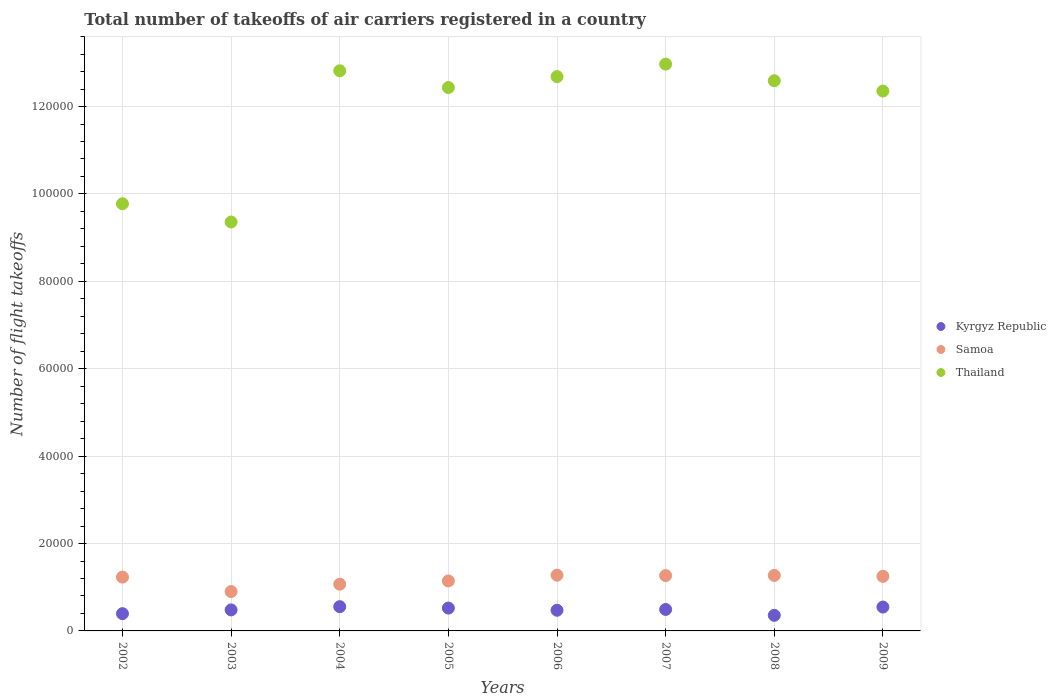How many different coloured dotlines are there?
Offer a terse response. 3. What is the total number of flight takeoffs in Kyrgyz Republic in 2006?
Provide a short and direct response. 4730. Across all years, what is the maximum total number of flight takeoffs in Samoa?
Provide a succinct answer. 1.28e+04. Across all years, what is the minimum total number of flight takeoffs in Kyrgyz Republic?
Your answer should be very brief. 3567. In which year was the total number of flight takeoffs in Thailand minimum?
Your answer should be very brief. 2003. What is the total total number of flight takeoffs in Thailand in the graph?
Keep it short and to the point. 9.50e+05. What is the difference between the total number of flight takeoffs in Samoa in 2002 and that in 2008?
Ensure brevity in your answer.  -382. What is the difference between the total number of flight takeoffs in Samoa in 2008 and the total number of flight takeoffs in Thailand in 2009?
Your response must be concise. -1.11e+05. What is the average total number of flight takeoffs in Samoa per year?
Your response must be concise. 1.18e+04. In the year 2006, what is the difference between the total number of flight takeoffs in Kyrgyz Republic and total number of flight takeoffs in Thailand?
Make the answer very short. -1.22e+05. In how many years, is the total number of flight takeoffs in Kyrgyz Republic greater than 4000?
Your answer should be compact. 6. What is the ratio of the total number of flight takeoffs in Kyrgyz Republic in 2003 to that in 2005?
Keep it short and to the point. 0.92. Is the total number of flight takeoffs in Kyrgyz Republic in 2006 less than that in 2009?
Provide a short and direct response. Yes. Is the difference between the total number of flight takeoffs in Kyrgyz Republic in 2002 and 2007 greater than the difference between the total number of flight takeoffs in Thailand in 2002 and 2007?
Ensure brevity in your answer.  Yes. What is the difference between the highest and the second highest total number of flight takeoffs in Kyrgyz Republic?
Give a very brief answer. 91. What is the difference between the highest and the lowest total number of flight takeoffs in Samoa?
Make the answer very short. 3742. Is the sum of the total number of flight takeoffs in Kyrgyz Republic in 2008 and 2009 greater than the maximum total number of flight takeoffs in Samoa across all years?
Give a very brief answer. No. Does the total number of flight takeoffs in Kyrgyz Republic monotonically increase over the years?
Provide a short and direct response. No. Is the total number of flight takeoffs in Thailand strictly less than the total number of flight takeoffs in Kyrgyz Republic over the years?
Your answer should be very brief. No. How many years are there in the graph?
Ensure brevity in your answer.  8. Are the values on the major ticks of Y-axis written in scientific E-notation?
Provide a succinct answer. No. Does the graph contain any zero values?
Provide a short and direct response. No. How many legend labels are there?
Offer a very short reply. 3. What is the title of the graph?
Your answer should be very brief. Total number of takeoffs of air carriers registered in a country. Does "Bosnia and Herzegovina" appear as one of the legend labels in the graph?
Ensure brevity in your answer.  No. What is the label or title of the Y-axis?
Offer a very short reply. Number of flight takeoffs. What is the Number of flight takeoffs in Kyrgyz Republic in 2002?
Offer a very short reply. 3951. What is the Number of flight takeoffs in Samoa in 2002?
Offer a terse response. 1.23e+04. What is the Number of flight takeoffs in Thailand in 2002?
Provide a succinct answer. 9.78e+04. What is the Number of flight takeoffs of Kyrgyz Republic in 2003?
Offer a very short reply. 4810. What is the Number of flight takeoffs of Samoa in 2003?
Your answer should be compact. 9010. What is the Number of flight takeoffs in Thailand in 2003?
Provide a short and direct response. 9.36e+04. What is the Number of flight takeoffs in Kyrgyz Republic in 2004?
Give a very brief answer. 5550. What is the Number of flight takeoffs of Samoa in 2004?
Your response must be concise. 1.07e+04. What is the Number of flight takeoffs in Thailand in 2004?
Offer a terse response. 1.28e+05. What is the Number of flight takeoffs of Kyrgyz Republic in 2005?
Ensure brevity in your answer.  5228. What is the Number of flight takeoffs of Samoa in 2005?
Keep it short and to the point. 1.14e+04. What is the Number of flight takeoffs in Thailand in 2005?
Provide a short and direct response. 1.24e+05. What is the Number of flight takeoffs of Kyrgyz Republic in 2006?
Offer a very short reply. 4730. What is the Number of flight takeoffs of Samoa in 2006?
Provide a succinct answer. 1.28e+04. What is the Number of flight takeoffs in Thailand in 2006?
Offer a very short reply. 1.27e+05. What is the Number of flight takeoffs of Kyrgyz Republic in 2007?
Provide a succinct answer. 4916. What is the Number of flight takeoffs of Samoa in 2007?
Make the answer very short. 1.27e+04. What is the Number of flight takeoffs of Thailand in 2007?
Your answer should be very brief. 1.30e+05. What is the Number of flight takeoffs of Kyrgyz Republic in 2008?
Ensure brevity in your answer.  3567. What is the Number of flight takeoffs in Samoa in 2008?
Give a very brief answer. 1.27e+04. What is the Number of flight takeoffs of Thailand in 2008?
Make the answer very short. 1.26e+05. What is the Number of flight takeoffs of Kyrgyz Republic in 2009?
Give a very brief answer. 5459. What is the Number of flight takeoffs of Samoa in 2009?
Make the answer very short. 1.25e+04. What is the Number of flight takeoffs in Thailand in 2009?
Your response must be concise. 1.24e+05. Across all years, what is the maximum Number of flight takeoffs in Kyrgyz Republic?
Offer a very short reply. 5550. Across all years, what is the maximum Number of flight takeoffs of Samoa?
Keep it short and to the point. 1.28e+04. Across all years, what is the maximum Number of flight takeoffs of Thailand?
Make the answer very short. 1.30e+05. Across all years, what is the minimum Number of flight takeoffs in Kyrgyz Republic?
Your answer should be very brief. 3567. Across all years, what is the minimum Number of flight takeoffs in Samoa?
Ensure brevity in your answer.  9010. Across all years, what is the minimum Number of flight takeoffs of Thailand?
Provide a short and direct response. 9.36e+04. What is the total Number of flight takeoffs in Kyrgyz Republic in the graph?
Your response must be concise. 3.82e+04. What is the total Number of flight takeoffs of Samoa in the graph?
Your response must be concise. 9.41e+04. What is the total Number of flight takeoffs in Thailand in the graph?
Keep it short and to the point. 9.50e+05. What is the difference between the Number of flight takeoffs of Kyrgyz Republic in 2002 and that in 2003?
Your answer should be very brief. -859. What is the difference between the Number of flight takeoffs in Samoa in 2002 and that in 2003?
Your answer should be compact. 3307. What is the difference between the Number of flight takeoffs in Thailand in 2002 and that in 2003?
Give a very brief answer. 4174. What is the difference between the Number of flight takeoffs of Kyrgyz Republic in 2002 and that in 2004?
Keep it short and to the point. -1599. What is the difference between the Number of flight takeoffs in Samoa in 2002 and that in 2004?
Offer a very short reply. 1626. What is the difference between the Number of flight takeoffs in Thailand in 2002 and that in 2004?
Provide a short and direct response. -3.04e+04. What is the difference between the Number of flight takeoffs in Kyrgyz Republic in 2002 and that in 2005?
Offer a very short reply. -1277. What is the difference between the Number of flight takeoffs in Samoa in 2002 and that in 2005?
Your response must be concise. 878. What is the difference between the Number of flight takeoffs in Thailand in 2002 and that in 2005?
Your answer should be very brief. -2.66e+04. What is the difference between the Number of flight takeoffs in Kyrgyz Republic in 2002 and that in 2006?
Make the answer very short. -779. What is the difference between the Number of flight takeoffs of Samoa in 2002 and that in 2006?
Your answer should be compact. -435. What is the difference between the Number of flight takeoffs in Thailand in 2002 and that in 2006?
Keep it short and to the point. -2.91e+04. What is the difference between the Number of flight takeoffs in Kyrgyz Republic in 2002 and that in 2007?
Provide a short and direct response. -965. What is the difference between the Number of flight takeoffs in Samoa in 2002 and that in 2007?
Make the answer very short. -341. What is the difference between the Number of flight takeoffs in Thailand in 2002 and that in 2007?
Give a very brief answer. -3.20e+04. What is the difference between the Number of flight takeoffs of Kyrgyz Republic in 2002 and that in 2008?
Offer a terse response. 384. What is the difference between the Number of flight takeoffs of Samoa in 2002 and that in 2008?
Offer a very short reply. -382. What is the difference between the Number of flight takeoffs of Thailand in 2002 and that in 2008?
Keep it short and to the point. -2.82e+04. What is the difference between the Number of flight takeoffs in Kyrgyz Republic in 2002 and that in 2009?
Provide a succinct answer. -1508. What is the difference between the Number of flight takeoffs of Samoa in 2002 and that in 2009?
Provide a short and direct response. -175. What is the difference between the Number of flight takeoffs of Thailand in 2002 and that in 2009?
Your answer should be compact. -2.58e+04. What is the difference between the Number of flight takeoffs in Kyrgyz Republic in 2003 and that in 2004?
Give a very brief answer. -740. What is the difference between the Number of flight takeoffs in Samoa in 2003 and that in 2004?
Your answer should be very brief. -1681. What is the difference between the Number of flight takeoffs of Thailand in 2003 and that in 2004?
Make the answer very short. -3.46e+04. What is the difference between the Number of flight takeoffs in Kyrgyz Republic in 2003 and that in 2005?
Keep it short and to the point. -418. What is the difference between the Number of flight takeoffs of Samoa in 2003 and that in 2005?
Your answer should be very brief. -2429. What is the difference between the Number of flight takeoffs of Thailand in 2003 and that in 2005?
Give a very brief answer. -3.08e+04. What is the difference between the Number of flight takeoffs in Kyrgyz Republic in 2003 and that in 2006?
Your answer should be very brief. 80. What is the difference between the Number of flight takeoffs of Samoa in 2003 and that in 2006?
Your answer should be very brief. -3742. What is the difference between the Number of flight takeoffs in Thailand in 2003 and that in 2006?
Make the answer very short. -3.33e+04. What is the difference between the Number of flight takeoffs in Kyrgyz Republic in 2003 and that in 2007?
Keep it short and to the point. -106. What is the difference between the Number of flight takeoffs of Samoa in 2003 and that in 2007?
Provide a succinct answer. -3648. What is the difference between the Number of flight takeoffs of Thailand in 2003 and that in 2007?
Your answer should be very brief. -3.61e+04. What is the difference between the Number of flight takeoffs in Kyrgyz Republic in 2003 and that in 2008?
Offer a terse response. 1243. What is the difference between the Number of flight takeoffs in Samoa in 2003 and that in 2008?
Offer a very short reply. -3689. What is the difference between the Number of flight takeoffs of Thailand in 2003 and that in 2008?
Offer a terse response. -3.23e+04. What is the difference between the Number of flight takeoffs of Kyrgyz Republic in 2003 and that in 2009?
Provide a short and direct response. -649. What is the difference between the Number of flight takeoffs in Samoa in 2003 and that in 2009?
Offer a terse response. -3482. What is the difference between the Number of flight takeoffs in Thailand in 2003 and that in 2009?
Your answer should be very brief. -3.00e+04. What is the difference between the Number of flight takeoffs of Kyrgyz Republic in 2004 and that in 2005?
Ensure brevity in your answer.  322. What is the difference between the Number of flight takeoffs of Samoa in 2004 and that in 2005?
Your answer should be compact. -748. What is the difference between the Number of flight takeoffs of Thailand in 2004 and that in 2005?
Your answer should be compact. 3831. What is the difference between the Number of flight takeoffs in Kyrgyz Republic in 2004 and that in 2006?
Provide a succinct answer. 820. What is the difference between the Number of flight takeoffs of Samoa in 2004 and that in 2006?
Your answer should be compact. -2061. What is the difference between the Number of flight takeoffs in Thailand in 2004 and that in 2006?
Offer a terse response. 1333. What is the difference between the Number of flight takeoffs of Kyrgyz Republic in 2004 and that in 2007?
Make the answer very short. 634. What is the difference between the Number of flight takeoffs of Samoa in 2004 and that in 2007?
Provide a succinct answer. -1967. What is the difference between the Number of flight takeoffs in Thailand in 2004 and that in 2007?
Provide a short and direct response. -1525. What is the difference between the Number of flight takeoffs of Kyrgyz Republic in 2004 and that in 2008?
Keep it short and to the point. 1983. What is the difference between the Number of flight takeoffs of Samoa in 2004 and that in 2008?
Make the answer very short. -2008. What is the difference between the Number of flight takeoffs of Thailand in 2004 and that in 2008?
Your response must be concise. 2271. What is the difference between the Number of flight takeoffs in Kyrgyz Republic in 2004 and that in 2009?
Give a very brief answer. 91. What is the difference between the Number of flight takeoffs in Samoa in 2004 and that in 2009?
Give a very brief answer. -1801. What is the difference between the Number of flight takeoffs in Thailand in 2004 and that in 2009?
Ensure brevity in your answer.  4637. What is the difference between the Number of flight takeoffs in Kyrgyz Republic in 2005 and that in 2006?
Provide a succinct answer. 498. What is the difference between the Number of flight takeoffs in Samoa in 2005 and that in 2006?
Make the answer very short. -1313. What is the difference between the Number of flight takeoffs in Thailand in 2005 and that in 2006?
Provide a succinct answer. -2498. What is the difference between the Number of flight takeoffs in Kyrgyz Republic in 2005 and that in 2007?
Your answer should be very brief. 312. What is the difference between the Number of flight takeoffs of Samoa in 2005 and that in 2007?
Ensure brevity in your answer.  -1219. What is the difference between the Number of flight takeoffs of Thailand in 2005 and that in 2007?
Ensure brevity in your answer.  -5356. What is the difference between the Number of flight takeoffs of Kyrgyz Republic in 2005 and that in 2008?
Provide a short and direct response. 1661. What is the difference between the Number of flight takeoffs of Samoa in 2005 and that in 2008?
Your answer should be very brief. -1260. What is the difference between the Number of flight takeoffs in Thailand in 2005 and that in 2008?
Your response must be concise. -1560. What is the difference between the Number of flight takeoffs of Kyrgyz Republic in 2005 and that in 2009?
Offer a terse response. -231. What is the difference between the Number of flight takeoffs in Samoa in 2005 and that in 2009?
Your response must be concise. -1053. What is the difference between the Number of flight takeoffs of Thailand in 2005 and that in 2009?
Offer a very short reply. 806. What is the difference between the Number of flight takeoffs of Kyrgyz Republic in 2006 and that in 2007?
Keep it short and to the point. -186. What is the difference between the Number of flight takeoffs in Samoa in 2006 and that in 2007?
Offer a terse response. 94. What is the difference between the Number of flight takeoffs in Thailand in 2006 and that in 2007?
Give a very brief answer. -2858. What is the difference between the Number of flight takeoffs of Kyrgyz Republic in 2006 and that in 2008?
Make the answer very short. 1163. What is the difference between the Number of flight takeoffs in Thailand in 2006 and that in 2008?
Your answer should be very brief. 938. What is the difference between the Number of flight takeoffs of Kyrgyz Republic in 2006 and that in 2009?
Provide a succinct answer. -729. What is the difference between the Number of flight takeoffs of Samoa in 2006 and that in 2009?
Your answer should be compact. 260. What is the difference between the Number of flight takeoffs in Thailand in 2006 and that in 2009?
Ensure brevity in your answer.  3304. What is the difference between the Number of flight takeoffs in Kyrgyz Republic in 2007 and that in 2008?
Your response must be concise. 1349. What is the difference between the Number of flight takeoffs in Samoa in 2007 and that in 2008?
Your response must be concise. -41. What is the difference between the Number of flight takeoffs in Thailand in 2007 and that in 2008?
Offer a terse response. 3796. What is the difference between the Number of flight takeoffs of Kyrgyz Republic in 2007 and that in 2009?
Ensure brevity in your answer.  -543. What is the difference between the Number of flight takeoffs in Samoa in 2007 and that in 2009?
Give a very brief answer. 166. What is the difference between the Number of flight takeoffs in Thailand in 2007 and that in 2009?
Provide a short and direct response. 6162. What is the difference between the Number of flight takeoffs in Kyrgyz Republic in 2008 and that in 2009?
Make the answer very short. -1892. What is the difference between the Number of flight takeoffs in Samoa in 2008 and that in 2009?
Keep it short and to the point. 207. What is the difference between the Number of flight takeoffs in Thailand in 2008 and that in 2009?
Give a very brief answer. 2366. What is the difference between the Number of flight takeoffs in Kyrgyz Republic in 2002 and the Number of flight takeoffs in Samoa in 2003?
Ensure brevity in your answer.  -5059. What is the difference between the Number of flight takeoffs in Kyrgyz Republic in 2002 and the Number of flight takeoffs in Thailand in 2003?
Provide a short and direct response. -8.96e+04. What is the difference between the Number of flight takeoffs in Samoa in 2002 and the Number of flight takeoffs in Thailand in 2003?
Your answer should be compact. -8.13e+04. What is the difference between the Number of flight takeoffs of Kyrgyz Republic in 2002 and the Number of flight takeoffs of Samoa in 2004?
Your response must be concise. -6740. What is the difference between the Number of flight takeoffs in Kyrgyz Republic in 2002 and the Number of flight takeoffs in Thailand in 2004?
Ensure brevity in your answer.  -1.24e+05. What is the difference between the Number of flight takeoffs in Samoa in 2002 and the Number of flight takeoffs in Thailand in 2004?
Provide a short and direct response. -1.16e+05. What is the difference between the Number of flight takeoffs of Kyrgyz Republic in 2002 and the Number of flight takeoffs of Samoa in 2005?
Your response must be concise. -7488. What is the difference between the Number of flight takeoffs of Kyrgyz Republic in 2002 and the Number of flight takeoffs of Thailand in 2005?
Keep it short and to the point. -1.20e+05. What is the difference between the Number of flight takeoffs in Samoa in 2002 and the Number of flight takeoffs in Thailand in 2005?
Make the answer very short. -1.12e+05. What is the difference between the Number of flight takeoffs in Kyrgyz Republic in 2002 and the Number of flight takeoffs in Samoa in 2006?
Make the answer very short. -8801. What is the difference between the Number of flight takeoffs in Kyrgyz Republic in 2002 and the Number of flight takeoffs in Thailand in 2006?
Give a very brief answer. -1.23e+05. What is the difference between the Number of flight takeoffs of Samoa in 2002 and the Number of flight takeoffs of Thailand in 2006?
Your response must be concise. -1.15e+05. What is the difference between the Number of flight takeoffs of Kyrgyz Republic in 2002 and the Number of flight takeoffs of Samoa in 2007?
Your answer should be very brief. -8707. What is the difference between the Number of flight takeoffs of Kyrgyz Republic in 2002 and the Number of flight takeoffs of Thailand in 2007?
Your response must be concise. -1.26e+05. What is the difference between the Number of flight takeoffs in Samoa in 2002 and the Number of flight takeoffs in Thailand in 2007?
Give a very brief answer. -1.17e+05. What is the difference between the Number of flight takeoffs of Kyrgyz Republic in 2002 and the Number of flight takeoffs of Samoa in 2008?
Provide a short and direct response. -8748. What is the difference between the Number of flight takeoffs in Kyrgyz Republic in 2002 and the Number of flight takeoffs in Thailand in 2008?
Offer a very short reply. -1.22e+05. What is the difference between the Number of flight takeoffs in Samoa in 2002 and the Number of flight takeoffs in Thailand in 2008?
Your answer should be compact. -1.14e+05. What is the difference between the Number of flight takeoffs in Kyrgyz Republic in 2002 and the Number of flight takeoffs in Samoa in 2009?
Make the answer very short. -8541. What is the difference between the Number of flight takeoffs of Kyrgyz Republic in 2002 and the Number of flight takeoffs of Thailand in 2009?
Keep it short and to the point. -1.20e+05. What is the difference between the Number of flight takeoffs of Samoa in 2002 and the Number of flight takeoffs of Thailand in 2009?
Provide a short and direct response. -1.11e+05. What is the difference between the Number of flight takeoffs in Kyrgyz Republic in 2003 and the Number of flight takeoffs in Samoa in 2004?
Offer a terse response. -5881. What is the difference between the Number of flight takeoffs of Kyrgyz Republic in 2003 and the Number of flight takeoffs of Thailand in 2004?
Provide a succinct answer. -1.23e+05. What is the difference between the Number of flight takeoffs in Samoa in 2003 and the Number of flight takeoffs in Thailand in 2004?
Offer a terse response. -1.19e+05. What is the difference between the Number of flight takeoffs in Kyrgyz Republic in 2003 and the Number of flight takeoffs in Samoa in 2005?
Provide a short and direct response. -6629. What is the difference between the Number of flight takeoffs of Kyrgyz Republic in 2003 and the Number of flight takeoffs of Thailand in 2005?
Your response must be concise. -1.20e+05. What is the difference between the Number of flight takeoffs in Samoa in 2003 and the Number of flight takeoffs in Thailand in 2005?
Ensure brevity in your answer.  -1.15e+05. What is the difference between the Number of flight takeoffs in Kyrgyz Republic in 2003 and the Number of flight takeoffs in Samoa in 2006?
Give a very brief answer. -7942. What is the difference between the Number of flight takeoffs in Kyrgyz Republic in 2003 and the Number of flight takeoffs in Thailand in 2006?
Ensure brevity in your answer.  -1.22e+05. What is the difference between the Number of flight takeoffs of Samoa in 2003 and the Number of flight takeoffs of Thailand in 2006?
Ensure brevity in your answer.  -1.18e+05. What is the difference between the Number of flight takeoffs of Kyrgyz Republic in 2003 and the Number of flight takeoffs of Samoa in 2007?
Provide a short and direct response. -7848. What is the difference between the Number of flight takeoffs of Kyrgyz Republic in 2003 and the Number of flight takeoffs of Thailand in 2007?
Your response must be concise. -1.25e+05. What is the difference between the Number of flight takeoffs of Samoa in 2003 and the Number of flight takeoffs of Thailand in 2007?
Offer a terse response. -1.21e+05. What is the difference between the Number of flight takeoffs of Kyrgyz Republic in 2003 and the Number of flight takeoffs of Samoa in 2008?
Give a very brief answer. -7889. What is the difference between the Number of flight takeoffs of Kyrgyz Republic in 2003 and the Number of flight takeoffs of Thailand in 2008?
Your answer should be very brief. -1.21e+05. What is the difference between the Number of flight takeoffs in Samoa in 2003 and the Number of flight takeoffs in Thailand in 2008?
Your answer should be compact. -1.17e+05. What is the difference between the Number of flight takeoffs of Kyrgyz Republic in 2003 and the Number of flight takeoffs of Samoa in 2009?
Your response must be concise. -7682. What is the difference between the Number of flight takeoffs in Kyrgyz Republic in 2003 and the Number of flight takeoffs in Thailand in 2009?
Provide a short and direct response. -1.19e+05. What is the difference between the Number of flight takeoffs of Samoa in 2003 and the Number of flight takeoffs of Thailand in 2009?
Provide a succinct answer. -1.15e+05. What is the difference between the Number of flight takeoffs in Kyrgyz Republic in 2004 and the Number of flight takeoffs in Samoa in 2005?
Your answer should be very brief. -5889. What is the difference between the Number of flight takeoffs of Kyrgyz Republic in 2004 and the Number of flight takeoffs of Thailand in 2005?
Your answer should be compact. -1.19e+05. What is the difference between the Number of flight takeoffs in Samoa in 2004 and the Number of flight takeoffs in Thailand in 2005?
Your answer should be compact. -1.14e+05. What is the difference between the Number of flight takeoffs in Kyrgyz Republic in 2004 and the Number of flight takeoffs in Samoa in 2006?
Your answer should be compact. -7202. What is the difference between the Number of flight takeoffs in Kyrgyz Republic in 2004 and the Number of flight takeoffs in Thailand in 2006?
Make the answer very short. -1.21e+05. What is the difference between the Number of flight takeoffs in Samoa in 2004 and the Number of flight takeoffs in Thailand in 2006?
Provide a succinct answer. -1.16e+05. What is the difference between the Number of flight takeoffs in Kyrgyz Republic in 2004 and the Number of flight takeoffs in Samoa in 2007?
Make the answer very short. -7108. What is the difference between the Number of flight takeoffs of Kyrgyz Republic in 2004 and the Number of flight takeoffs of Thailand in 2007?
Your answer should be very brief. -1.24e+05. What is the difference between the Number of flight takeoffs in Samoa in 2004 and the Number of flight takeoffs in Thailand in 2007?
Your answer should be compact. -1.19e+05. What is the difference between the Number of flight takeoffs of Kyrgyz Republic in 2004 and the Number of flight takeoffs of Samoa in 2008?
Your response must be concise. -7149. What is the difference between the Number of flight takeoffs of Kyrgyz Republic in 2004 and the Number of flight takeoffs of Thailand in 2008?
Offer a very short reply. -1.20e+05. What is the difference between the Number of flight takeoffs of Samoa in 2004 and the Number of flight takeoffs of Thailand in 2008?
Your answer should be compact. -1.15e+05. What is the difference between the Number of flight takeoffs in Kyrgyz Republic in 2004 and the Number of flight takeoffs in Samoa in 2009?
Offer a very short reply. -6942. What is the difference between the Number of flight takeoffs of Kyrgyz Republic in 2004 and the Number of flight takeoffs of Thailand in 2009?
Provide a succinct answer. -1.18e+05. What is the difference between the Number of flight takeoffs of Samoa in 2004 and the Number of flight takeoffs of Thailand in 2009?
Provide a succinct answer. -1.13e+05. What is the difference between the Number of flight takeoffs in Kyrgyz Republic in 2005 and the Number of flight takeoffs in Samoa in 2006?
Make the answer very short. -7524. What is the difference between the Number of flight takeoffs of Kyrgyz Republic in 2005 and the Number of flight takeoffs of Thailand in 2006?
Your answer should be compact. -1.22e+05. What is the difference between the Number of flight takeoffs in Samoa in 2005 and the Number of flight takeoffs in Thailand in 2006?
Your answer should be compact. -1.15e+05. What is the difference between the Number of flight takeoffs of Kyrgyz Republic in 2005 and the Number of flight takeoffs of Samoa in 2007?
Make the answer very short. -7430. What is the difference between the Number of flight takeoffs in Kyrgyz Republic in 2005 and the Number of flight takeoffs in Thailand in 2007?
Make the answer very short. -1.24e+05. What is the difference between the Number of flight takeoffs of Samoa in 2005 and the Number of flight takeoffs of Thailand in 2007?
Provide a succinct answer. -1.18e+05. What is the difference between the Number of flight takeoffs of Kyrgyz Republic in 2005 and the Number of flight takeoffs of Samoa in 2008?
Offer a very short reply. -7471. What is the difference between the Number of flight takeoffs in Kyrgyz Republic in 2005 and the Number of flight takeoffs in Thailand in 2008?
Your response must be concise. -1.21e+05. What is the difference between the Number of flight takeoffs in Samoa in 2005 and the Number of flight takeoffs in Thailand in 2008?
Provide a short and direct response. -1.14e+05. What is the difference between the Number of flight takeoffs of Kyrgyz Republic in 2005 and the Number of flight takeoffs of Samoa in 2009?
Ensure brevity in your answer.  -7264. What is the difference between the Number of flight takeoffs in Kyrgyz Republic in 2005 and the Number of flight takeoffs in Thailand in 2009?
Keep it short and to the point. -1.18e+05. What is the difference between the Number of flight takeoffs in Samoa in 2005 and the Number of flight takeoffs in Thailand in 2009?
Your response must be concise. -1.12e+05. What is the difference between the Number of flight takeoffs in Kyrgyz Republic in 2006 and the Number of flight takeoffs in Samoa in 2007?
Make the answer very short. -7928. What is the difference between the Number of flight takeoffs of Kyrgyz Republic in 2006 and the Number of flight takeoffs of Thailand in 2007?
Provide a succinct answer. -1.25e+05. What is the difference between the Number of flight takeoffs of Samoa in 2006 and the Number of flight takeoffs of Thailand in 2007?
Provide a succinct answer. -1.17e+05. What is the difference between the Number of flight takeoffs of Kyrgyz Republic in 2006 and the Number of flight takeoffs of Samoa in 2008?
Provide a succinct answer. -7969. What is the difference between the Number of flight takeoffs in Kyrgyz Republic in 2006 and the Number of flight takeoffs in Thailand in 2008?
Keep it short and to the point. -1.21e+05. What is the difference between the Number of flight takeoffs in Samoa in 2006 and the Number of flight takeoffs in Thailand in 2008?
Offer a very short reply. -1.13e+05. What is the difference between the Number of flight takeoffs of Kyrgyz Republic in 2006 and the Number of flight takeoffs of Samoa in 2009?
Keep it short and to the point. -7762. What is the difference between the Number of flight takeoffs in Kyrgyz Republic in 2006 and the Number of flight takeoffs in Thailand in 2009?
Your answer should be compact. -1.19e+05. What is the difference between the Number of flight takeoffs in Samoa in 2006 and the Number of flight takeoffs in Thailand in 2009?
Provide a succinct answer. -1.11e+05. What is the difference between the Number of flight takeoffs in Kyrgyz Republic in 2007 and the Number of flight takeoffs in Samoa in 2008?
Ensure brevity in your answer.  -7783. What is the difference between the Number of flight takeoffs of Kyrgyz Republic in 2007 and the Number of flight takeoffs of Thailand in 2008?
Offer a very short reply. -1.21e+05. What is the difference between the Number of flight takeoffs of Samoa in 2007 and the Number of flight takeoffs of Thailand in 2008?
Your answer should be compact. -1.13e+05. What is the difference between the Number of flight takeoffs of Kyrgyz Republic in 2007 and the Number of flight takeoffs of Samoa in 2009?
Make the answer very short. -7576. What is the difference between the Number of flight takeoffs of Kyrgyz Republic in 2007 and the Number of flight takeoffs of Thailand in 2009?
Ensure brevity in your answer.  -1.19e+05. What is the difference between the Number of flight takeoffs in Samoa in 2007 and the Number of flight takeoffs in Thailand in 2009?
Provide a short and direct response. -1.11e+05. What is the difference between the Number of flight takeoffs of Kyrgyz Republic in 2008 and the Number of flight takeoffs of Samoa in 2009?
Your answer should be compact. -8925. What is the difference between the Number of flight takeoffs of Kyrgyz Republic in 2008 and the Number of flight takeoffs of Thailand in 2009?
Offer a very short reply. -1.20e+05. What is the difference between the Number of flight takeoffs in Samoa in 2008 and the Number of flight takeoffs in Thailand in 2009?
Your answer should be compact. -1.11e+05. What is the average Number of flight takeoffs of Kyrgyz Republic per year?
Your response must be concise. 4776.38. What is the average Number of flight takeoffs of Samoa per year?
Your response must be concise. 1.18e+04. What is the average Number of flight takeoffs of Thailand per year?
Offer a terse response. 1.19e+05. In the year 2002, what is the difference between the Number of flight takeoffs of Kyrgyz Republic and Number of flight takeoffs of Samoa?
Offer a terse response. -8366. In the year 2002, what is the difference between the Number of flight takeoffs of Kyrgyz Republic and Number of flight takeoffs of Thailand?
Your answer should be very brief. -9.38e+04. In the year 2002, what is the difference between the Number of flight takeoffs in Samoa and Number of flight takeoffs in Thailand?
Your response must be concise. -8.54e+04. In the year 2003, what is the difference between the Number of flight takeoffs of Kyrgyz Republic and Number of flight takeoffs of Samoa?
Ensure brevity in your answer.  -4200. In the year 2003, what is the difference between the Number of flight takeoffs of Kyrgyz Republic and Number of flight takeoffs of Thailand?
Give a very brief answer. -8.88e+04. In the year 2003, what is the difference between the Number of flight takeoffs in Samoa and Number of flight takeoffs in Thailand?
Provide a short and direct response. -8.46e+04. In the year 2004, what is the difference between the Number of flight takeoffs of Kyrgyz Republic and Number of flight takeoffs of Samoa?
Your response must be concise. -5141. In the year 2004, what is the difference between the Number of flight takeoffs of Kyrgyz Republic and Number of flight takeoffs of Thailand?
Keep it short and to the point. -1.23e+05. In the year 2004, what is the difference between the Number of flight takeoffs of Samoa and Number of flight takeoffs of Thailand?
Your answer should be compact. -1.17e+05. In the year 2005, what is the difference between the Number of flight takeoffs in Kyrgyz Republic and Number of flight takeoffs in Samoa?
Make the answer very short. -6211. In the year 2005, what is the difference between the Number of flight takeoffs of Kyrgyz Republic and Number of flight takeoffs of Thailand?
Ensure brevity in your answer.  -1.19e+05. In the year 2005, what is the difference between the Number of flight takeoffs in Samoa and Number of flight takeoffs in Thailand?
Your answer should be very brief. -1.13e+05. In the year 2006, what is the difference between the Number of flight takeoffs in Kyrgyz Republic and Number of flight takeoffs in Samoa?
Offer a terse response. -8022. In the year 2006, what is the difference between the Number of flight takeoffs in Kyrgyz Republic and Number of flight takeoffs in Thailand?
Offer a terse response. -1.22e+05. In the year 2006, what is the difference between the Number of flight takeoffs in Samoa and Number of flight takeoffs in Thailand?
Offer a terse response. -1.14e+05. In the year 2007, what is the difference between the Number of flight takeoffs of Kyrgyz Republic and Number of flight takeoffs of Samoa?
Offer a very short reply. -7742. In the year 2007, what is the difference between the Number of flight takeoffs in Kyrgyz Republic and Number of flight takeoffs in Thailand?
Keep it short and to the point. -1.25e+05. In the year 2007, what is the difference between the Number of flight takeoffs in Samoa and Number of flight takeoffs in Thailand?
Keep it short and to the point. -1.17e+05. In the year 2008, what is the difference between the Number of flight takeoffs in Kyrgyz Republic and Number of flight takeoffs in Samoa?
Keep it short and to the point. -9132. In the year 2008, what is the difference between the Number of flight takeoffs of Kyrgyz Republic and Number of flight takeoffs of Thailand?
Your answer should be compact. -1.22e+05. In the year 2008, what is the difference between the Number of flight takeoffs of Samoa and Number of flight takeoffs of Thailand?
Ensure brevity in your answer.  -1.13e+05. In the year 2009, what is the difference between the Number of flight takeoffs of Kyrgyz Republic and Number of flight takeoffs of Samoa?
Your answer should be compact. -7033. In the year 2009, what is the difference between the Number of flight takeoffs of Kyrgyz Republic and Number of flight takeoffs of Thailand?
Make the answer very short. -1.18e+05. In the year 2009, what is the difference between the Number of flight takeoffs of Samoa and Number of flight takeoffs of Thailand?
Offer a very short reply. -1.11e+05. What is the ratio of the Number of flight takeoffs of Kyrgyz Republic in 2002 to that in 2003?
Provide a short and direct response. 0.82. What is the ratio of the Number of flight takeoffs in Samoa in 2002 to that in 2003?
Offer a very short reply. 1.37. What is the ratio of the Number of flight takeoffs of Thailand in 2002 to that in 2003?
Keep it short and to the point. 1.04. What is the ratio of the Number of flight takeoffs of Kyrgyz Republic in 2002 to that in 2004?
Ensure brevity in your answer.  0.71. What is the ratio of the Number of flight takeoffs in Samoa in 2002 to that in 2004?
Make the answer very short. 1.15. What is the ratio of the Number of flight takeoffs in Thailand in 2002 to that in 2004?
Ensure brevity in your answer.  0.76. What is the ratio of the Number of flight takeoffs in Kyrgyz Republic in 2002 to that in 2005?
Your answer should be very brief. 0.76. What is the ratio of the Number of flight takeoffs of Samoa in 2002 to that in 2005?
Your answer should be very brief. 1.08. What is the ratio of the Number of flight takeoffs in Thailand in 2002 to that in 2005?
Give a very brief answer. 0.79. What is the ratio of the Number of flight takeoffs in Kyrgyz Republic in 2002 to that in 2006?
Provide a succinct answer. 0.84. What is the ratio of the Number of flight takeoffs in Samoa in 2002 to that in 2006?
Make the answer very short. 0.97. What is the ratio of the Number of flight takeoffs of Thailand in 2002 to that in 2006?
Give a very brief answer. 0.77. What is the ratio of the Number of flight takeoffs of Kyrgyz Republic in 2002 to that in 2007?
Ensure brevity in your answer.  0.8. What is the ratio of the Number of flight takeoffs in Samoa in 2002 to that in 2007?
Your response must be concise. 0.97. What is the ratio of the Number of flight takeoffs of Thailand in 2002 to that in 2007?
Ensure brevity in your answer.  0.75. What is the ratio of the Number of flight takeoffs of Kyrgyz Republic in 2002 to that in 2008?
Provide a succinct answer. 1.11. What is the ratio of the Number of flight takeoffs of Samoa in 2002 to that in 2008?
Your answer should be very brief. 0.97. What is the ratio of the Number of flight takeoffs in Thailand in 2002 to that in 2008?
Your answer should be very brief. 0.78. What is the ratio of the Number of flight takeoffs in Kyrgyz Republic in 2002 to that in 2009?
Provide a short and direct response. 0.72. What is the ratio of the Number of flight takeoffs in Thailand in 2002 to that in 2009?
Provide a short and direct response. 0.79. What is the ratio of the Number of flight takeoffs in Kyrgyz Republic in 2003 to that in 2004?
Offer a terse response. 0.87. What is the ratio of the Number of flight takeoffs of Samoa in 2003 to that in 2004?
Give a very brief answer. 0.84. What is the ratio of the Number of flight takeoffs in Thailand in 2003 to that in 2004?
Your answer should be very brief. 0.73. What is the ratio of the Number of flight takeoffs in Samoa in 2003 to that in 2005?
Provide a succinct answer. 0.79. What is the ratio of the Number of flight takeoffs in Thailand in 2003 to that in 2005?
Provide a short and direct response. 0.75. What is the ratio of the Number of flight takeoffs in Kyrgyz Republic in 2003 to that in 2006?
Your answer should be compact. 1.02. What is the ratio of the Number of flight takeoffs in Samoa in 2003 to that in 2006?
Offer a very short reply. 0.71. What is the ratio of the Number of flight takeoffs of Thailand in 2003 to that in 2006?
Make the answer very short. 0.74. What is the ratio of the Number of flight takeoffs of Kyrgyz Republic in 2003 to that in 2007?
Give a very brief answer. 0.98. What is the ratio of the Number of flight takeoffs in Samoa in 2003 to that in 2007?
Give a very brief answer. 0.71. What is the ratio of the Number of flight takeoffs in Thailand in 2003 to that in 2007?
Offer a terse response. 0.72. What is the ratio of the Number of flight takeoffs in Kyrgyz Republic in 2003 to that in 2008?
Provide a succinct answer. 1.35. What is the ratio of the Number of flight takeoffs in Samoa in 2003 to that in 2008?
Make the answer very short. 0.71. What is the ratio of the Number of flight takeoffs of Thailand in 2003 to that in 2008?
Make the answer very short. 0.74. What is the ratio of the Number of flight takeoffs of Kyrgyz Republic in 2003 to that in 2009?
Offer a terse response. 0.88. What is the ratio of the Number of flight takeoffs of Samoa in 2003 to that in 2009?
Make the answer very short. 0.72. What is the ratio of the Number of flight takeoffs in Thailand in 2003 to that in 2009?
Offer a very short reply. 0.76. What is the ratio of the Number of flight takeoffs in Kyrgyz Republic in 2004 to that in 2005?
Your answer should be compact. 1.06. What is the ratio of the Number of flight takeoffs in Samoa in 2004 to that in 2005?
Your answer should be very brief. 0.93. What is the ratio of the Number of flight takeoffs in Thailand in 2004 to that in 2005?
Give a very brief answer. 1.03. What is the ratio of the Number of flight takeoffs in Kyrgyz Republic in 2004 to that in 2006?
Keep it short and to the point. 1.17. What is the ratio of the Number of flight takeoffs of Samoa in 2004 to that in 2006?
Make the answer very short. 0.84. What is the ratio of the Number of flight takeoffs of Thailand in 2004 to that in 2006?
Your answer should be very brief. 1.01. What is the ratio of the Number of flight takeoffs of Kyrgyz Republic in 2004 to that in 2007?
Keep it short and to the point. 1.13. What is the ratio of the Number of flight takeoffs of Samoa in 2004 to that in 2007?
Make the answer very short. 0.84. What is the ratio of the Number of flight takeoffs of Thailand in 2004 to that in 2007?
Your answer should be compact. 0.99. What is the ratio of the Number of flight takeoffs of Kyrgyz Republic in 2004 to that in 2008?
Provide a short and direct response. 1.56. What is the ratio of the Number of flight takeoffs of Samoa in 2004 to that in 2008?
Offer a very short reply. 0.84. What is the ratio of the Number of flight takeoffs in Kyrgyz Republic in 2004 to that in 2009?
Provide a short and direct response. 1.02. What is the ratio of the Number of flight takeoffs in Samoa in 2004 to that in 2009?
Your answer should be compact. 0.86. What is the ratio of the Number of flight takeoffs in Thailand in 2004 to that in 2009?
Give a very brief answer. 1.04. What is the ratio of the Number of flight takeoffs of Kyrgyz Republic in 2005 to that in 2006?
Provide a succinct answer. 1.11. What is the ratio of the Number of flight takeoffs of Samoa in 2005 to that in 2006?
Give a very brief answer. 0.9. What is the ratio of the Number of flight takeoffs of Thailand in 2005 to that in 2006?
Give a very brief answer. 0.98. What is the ratio of the Number of flight takeoffs in Kyrgyz Republic in 2005 to that in 2007?
Your answer should be compact. 1.06. What is the ratio of the Number of flight takeoffs in Samoa in 2005 to that in 2007?
Offer a terse response. 0.9. What is the ratio of the Number of flight takeoffs in Thailand in 2005 to that in 2007?
Make the answer very short. 0.96. What is the ratio of the Number of flight takeoffs in Kyrgyz Republic in 2005 to that in 2008?
Provide a succinct answer. 1.47. What is the ratio of the Number of flight takeoffs in Samoa in 2005 to that in 2008?
Give a very brief answer. 0.9. What is the ratio of the Number of flight takeoffs in Thailand in 2005 to that in 2008?
Offer a terse response. 0.99. What is the ratio of the Number of flight takeoffs in Kyrgyz Republic in 2005 to that in 2009?
Keep it short and to the point. 0.96. What is the ratio of the Number of flight takeoffs in Samoa in 2005 to that in 2009?
Give a very brief answer. 0.92. What is the ratio of the Number of flight takeoffs of Thailand in 2005 to that in 2009?
Your answer should be very brief. 1.01. What is the ratio of the Number of flight takeoffs in Kyrgyz Republic in 2006 to that in 2007?
Provide a succinct answer. 0.96. What is the ratio of the Number of flight takeoffs of Samoa in 2006 to that in 2007?
Provide a succinct answer. 1.01. What is the ratio of the Number of flight takeoffs in Thailand in 2006 to that in 2007?
Provide a short and direct response. 0.98. What is the ratio of the Number of flight takeoffs of Kyrgyz Republic in 2006 to that in 2008?
Offer a very short reply. 1.33. What is the ratio of the Number of flight takeoffs in Samoa in 2006 to that in 2008?
Offer a terse response. 1. What is the ratio of the Number of flight takeoffs in Thailand in 2006 to that in 2008?
Provide a succinct answer. 1.01. What is the ratio of the Number of flight takeoffs in Kyrgyz Republic in 2006 to that in 2009?
Provide a succinct answer. 0.87. What is the ratio of the Number of flight takeoffs in Samoa in 2006 to that in 2009?
Give a very brief answer. 1.02. What is the ratio of the Number of flight takeoffs in Thailand in 2006 to that in 2009?
Provide a short and direct response. 1.03. What is the ratio of the Number of flight takeoffs of Kyrgyz Republic in 2007 to that in 2008?
Your answer should be compact. 1.38. What is the ratio of the Number of flight takeoffs of Samoa in 2007 to that in 2008?
Keep it short and to the point. 1. What is the ratio of the Number of flight takeoffs in Thailand in 2007 to that in 2008?
Your answer should be very brief. 1.03. What is the ratio of the Number of flight takeoffs of Kyrgyz Republic in 2007 to that in 2009?
Ensure brevity in your answer.  0.9. What is the ratio of the Number of flight takeoffs in Samoa in 2007 to that in 2009?
Your answer should be compact. 1.01. What is the ratio of the Number of flight takeoffs in Thailand in 2007 to that in 2009?
Offer a terse response. 1.05. What is the ratio of the Number of flight takeoffs in Kyrgyz Republic in 2008 to that in 2009?
Your answer should be compact. 0.65. What is the ratio of the Number of flight takeoffs of Samoa in 2008 to that in 2009?
Your response must be concise. 1.02. What is the ratio of the Number of flight takeoffs in Thailand in 2008 to that in 2009?
Your response must be concise. 1.02. What is the difference between the highest and the second highest Number of flight takeoffs of Kyrgyz Republic?
Give a very brief answer. 91. What is the difference between the highest and the second highest Number of flight takeoffs in Thailand?
Ensure brevity in your answer.  1525. What is the difference between the highest and the lowest Number of flight takeoffs in Kyrgyz Republic?
Give a very brief answer. 1983. What is the difference between the highest and the lowest Number of flight takeoffs in Samoa?
Make the answer very short. 3742. What is the difference between the highest and the lowest Number of flight takeoffs in Thailand?
Keep it short and to the point. 3.61e+04. 